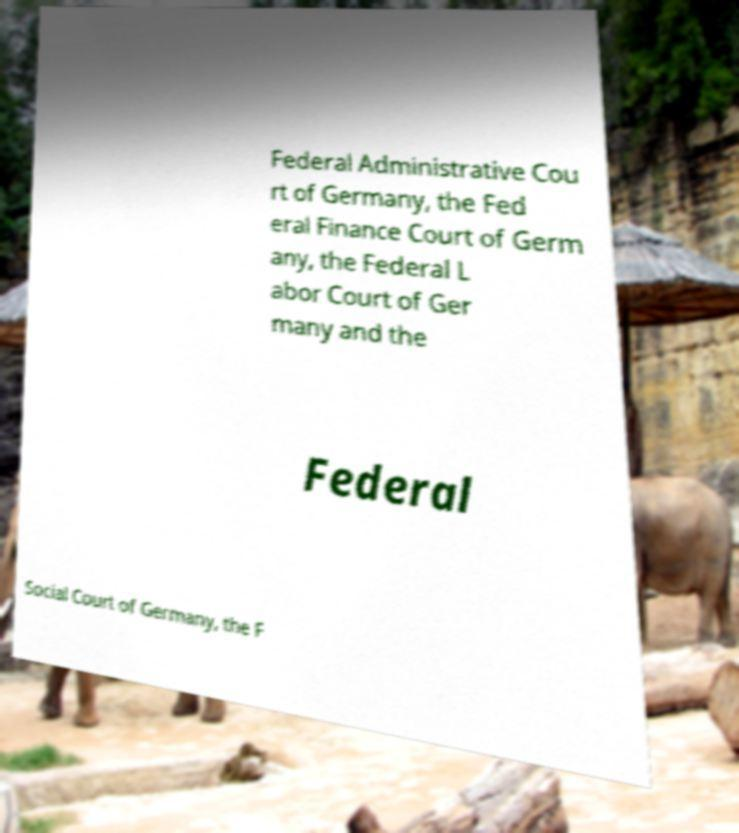For documentation purposes, I need the text within this image transcribed. Could you provide that? Federal Administrative Cou rt of Germany, the Fed eral Finance Court of Germ any, the Federal L abor Court of Ger many and the Federal Social Court of Germany, the F 